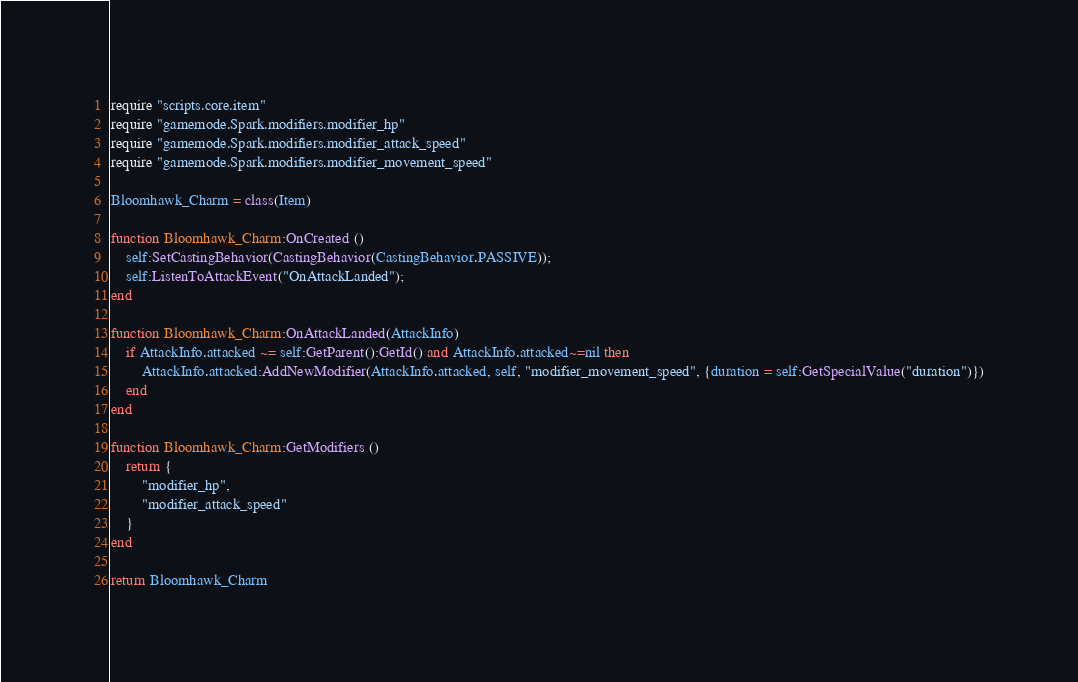<code> <loc_0><loc_0><loc_500><loc_500><_Lua_>require "scripts.core.item"
require "gamemode.Spark.modifiers.modifier_hp"
require "gamemode.Spark.modifiers.modifier_attack_speed"
require "gamemode.Spark.modifiers.modifier_movement_speed"

Bloomhawk_Charm = class(Item)

function Bloomhawk_Charm:OnCreated ()
	self:SetCastingBehavior(CastingBehavior(CastingBehavior.PASSIVE));
	self:ListenToAttackEvent("OnAttackLanded");
end

function Bloomhawk_Charm:OnAttackLanded(AttackInfo)
	if AttackInfo.attacked ~= self:GetParent():GetId() and AttackInfo.attacked~=nil then
		AttackInfo.attacked:AddNewModifier(AttackInfo.attacked, self, "modifier_movement_speed", {duration = self:GetSpecialValue("duration")})
	end
end

function Bloomhawk_Charm:GetModifiers ()
	return {
		"modifier_hp",
		"modifier_attack_speed"		
	}
end

return Bloomhawk_Charm</code> 